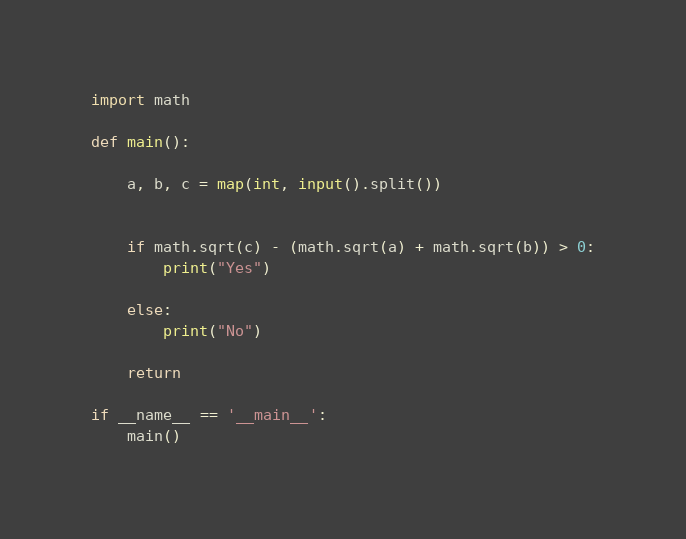<code> <loc_0><loc_0><loc_500><loc_500><_Python_>import math

def main():
 
    a, b, c = map(int, input().split())
 
 
    if math.sqrt(c) - (math.sqrt(a) + math.sqrt(b)) > 0:
        print("Yes")
 
    else:
        print("No")
 
    return
 
if __name__ == '__main__':
    main()</code> 